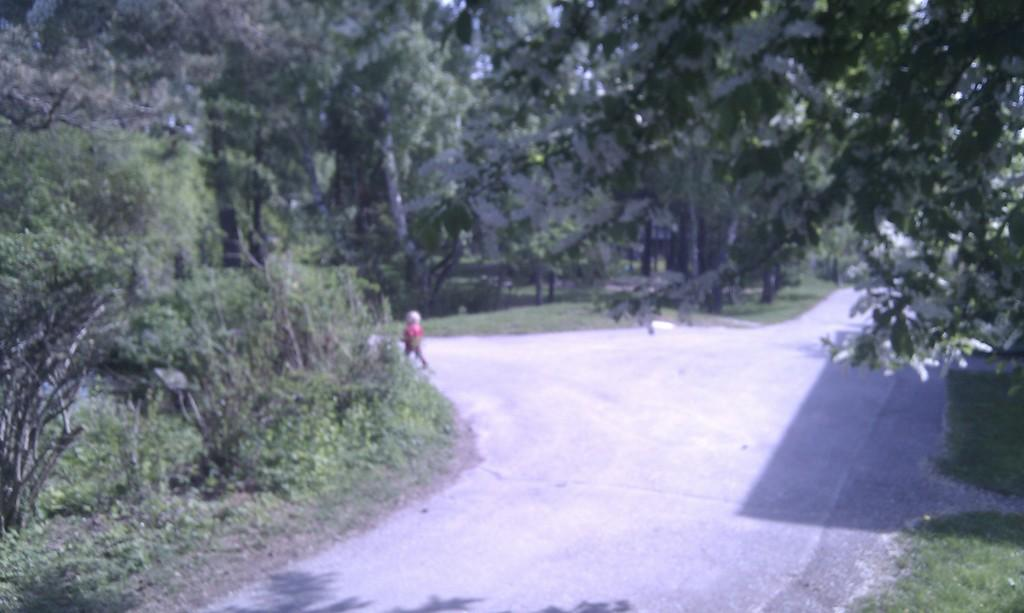What is happening in the image? There is a person on the road in the image. What type of vegetation can be seen in the image? There is grass visible in the image. What can be seen in the background of the image? There are trees in the background of the image. How many sheep are present in the image? There are no sheep present in the image. Is the person in the image showing any signs of anger? The image does not provide any information about the person's emotions, so it cannot be determined if they are showing signs of anger. 